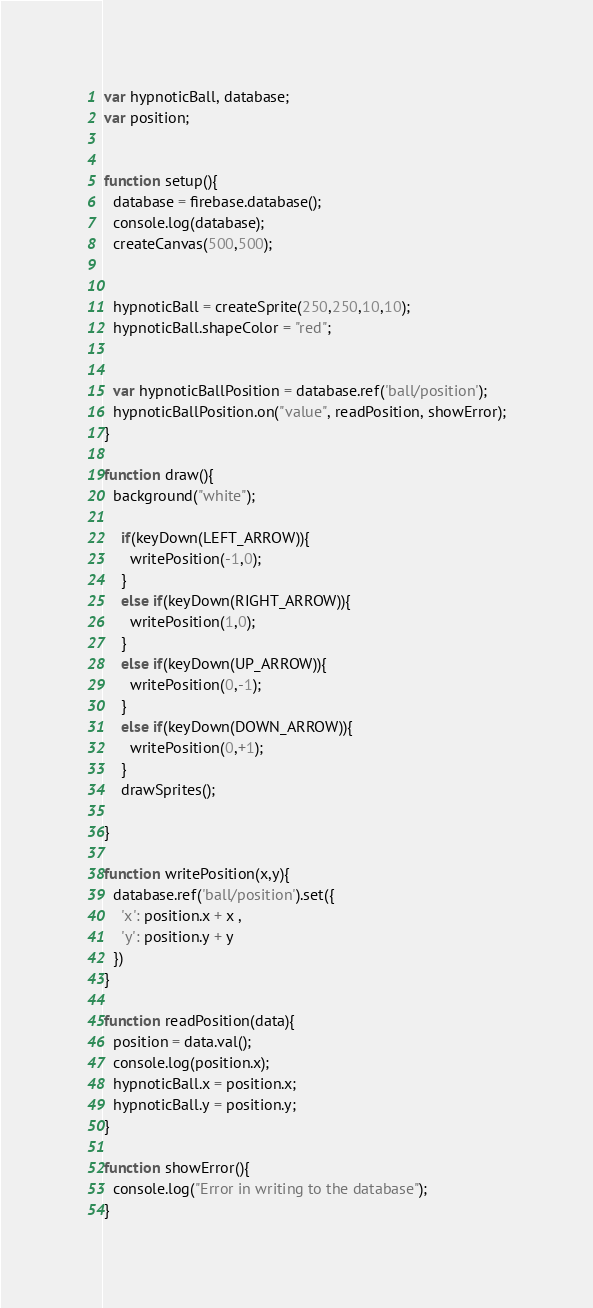Convert code to text. <code><loc_0><loc_0><loc_500><loc_500><_JavaScript_>var hypnoticBall, database;
var position;


function setup(){
  database = firebase.database();
  console.log(database);
  createCanvas(500,500);

  
  hypnoticBall = createSprite(250,250,10,10);
  hypnoticBall.shapeColor = "red";


  var hypnoticBallPosition = database.ref('ball/position');
  hypnoticBallPosition.on("value", readPosition, showError);
}

function draw(){
  background("white");
  
    if(keyDown(LEFT_ARROW)){
      writePosition(-1,0);
    }
    else if(keyDown(RIGHT_ARROW)){
      writePosition(1,0);
    }
    else if(keyDown(UP_ARROW)){
      writePosition(0,-1);
    }
    else if(keyDown(DOWN_ARROW)){
      writePosition(0,+1);
    }
    drawSprites();
  
}

function writePosition(x,y){
  database.ref('ball/position').set({
    'x': position.x + x ,
    'y': position.y + y
  })
}

function readPosition(data){
  position = data.val();
  console.log(position.x);
  hypnoticBall.x = position.x;
  hypnoticBall.y = position.y;
}

function showError(){
  console.log("Error in writing to the database");
}
</code> 